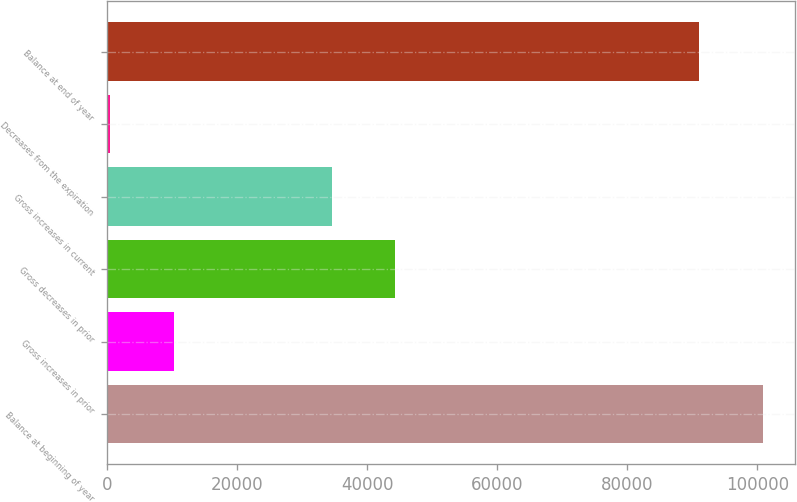<chart> <loc_0><loc_0><loc_500><loc_500><bar_chart><fcel>Balance at beginning of year<fcel>Gross increases in prior<fcel>Gross decreases in prior<fcel>Gross increases in current<fcel>Decreases from the expiration<fcel>Balance at end of year<nl><fcel>100846<fcel>10228.5<fcel>44334.5<fcel>34598<fcel>492<fcel>91109<nl></chart> 